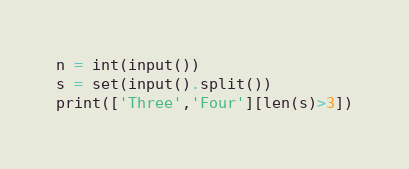<code> <loc_0><loc_0><loc_500><loc_500><_Python_>n = int(input())
s = set(input().split())
print(['Three','Four'][len(s)>3])
</code> 